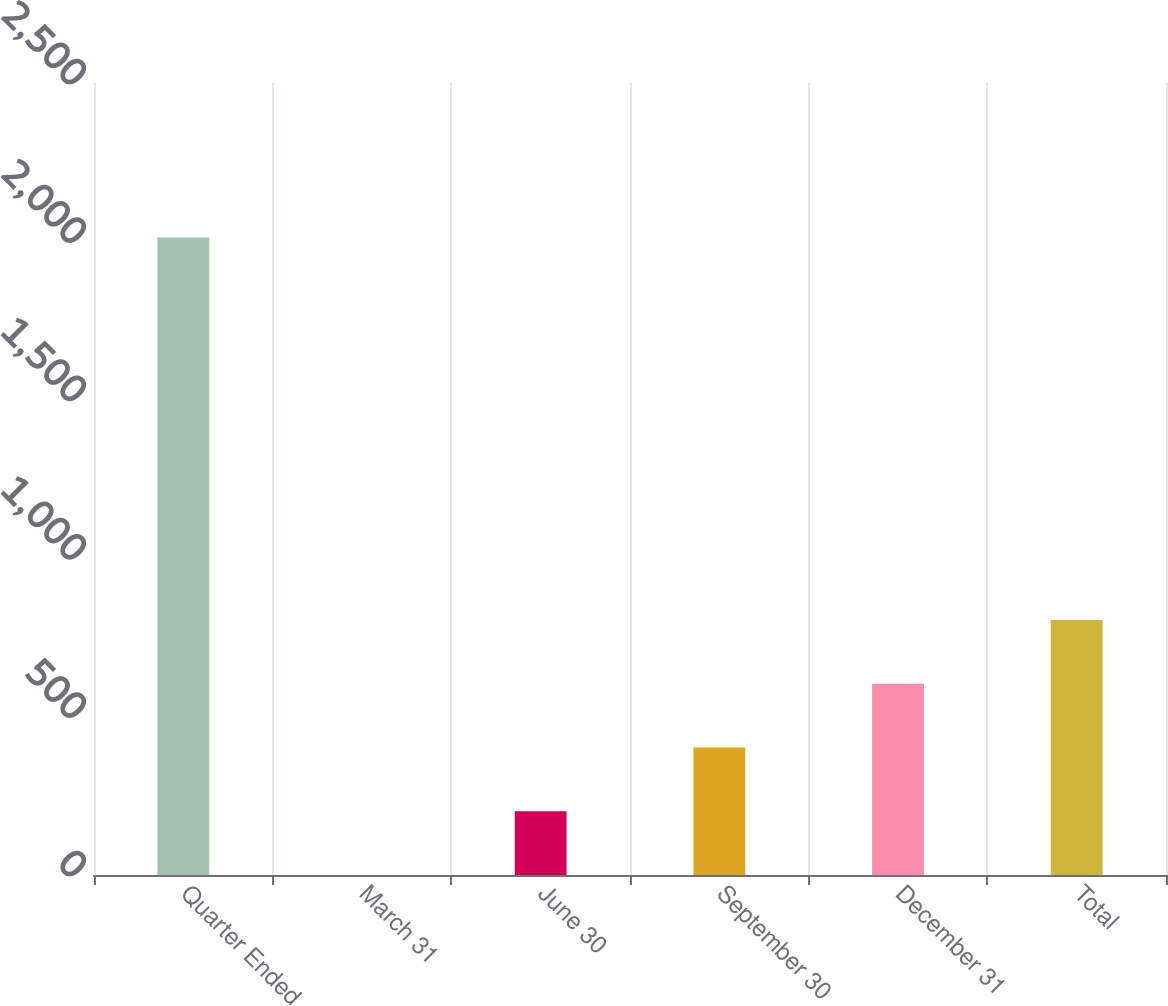Convert chart to OTSL. <chart><loc_0><loc_0><loc_500><loc_500><bar_chart><fcel>Quarter Ended<fcel>March 31<fcel>June 30<fcel>September 30<fcel>December 31<fcel>Total<nl><fcel>2012<fcel>0.29<fcel>201.46<fcel>402.63<fcel>603.8<fcel>804.97<nl></chart> 